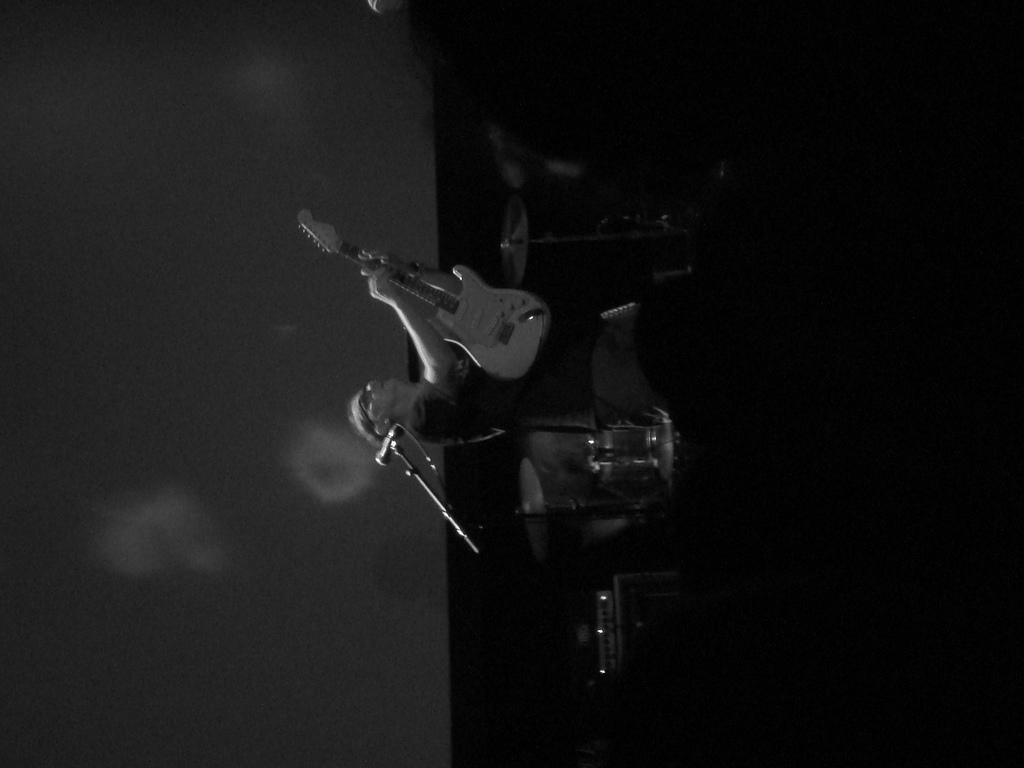Describe this image in one or two sentences. In the center of the image there is a person holding a guitar. This is a black and white image. 